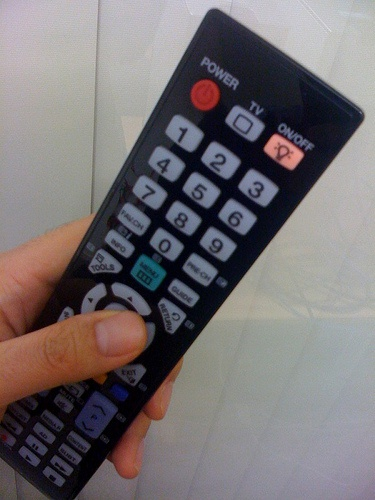Describe the objects in this image and their specific colors. I can see remote in darkgray, black, and gray tones and people in darkgray, brown, maroon, and salmon tones in this image. 